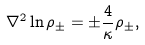Convert formula to latex. <formula><loc_0><loc_0><loc_500><loc_500>{ \nabla } ^ { 2 } \ln { \rho } _ { \pm } = { \pm } { \frac { 4 } { \kappa } } { \rho } _ { \pm } ,</formula> 